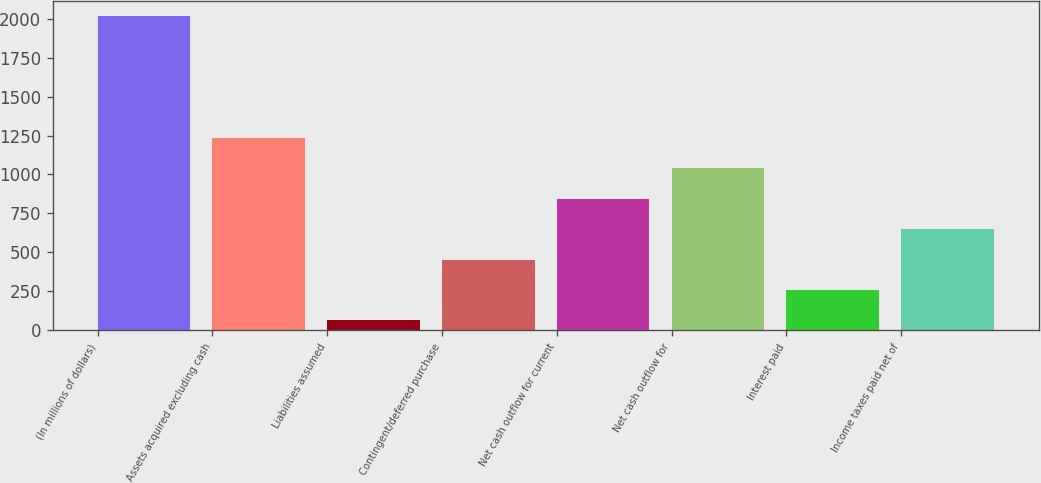Convert chart. <chart><loc_0><loc_0><loc_500><loc_500><bar_chart><fcel>(In millions of dollars)<fcel>Assets acquired excluding cash<fcel>Liabilities assumed<fcel>Contingent/deferred purchase<fcel>Net cash outflow for current<fcel>Net cash outflow for<fcel>Interest paid<fcel>Income taxes paid net of<nl><fcel>2014<fcel>1234<fcel>64<fcel>454<fcel>844<fcel>1039<fcel>259<fcel>649<nl></chart> 